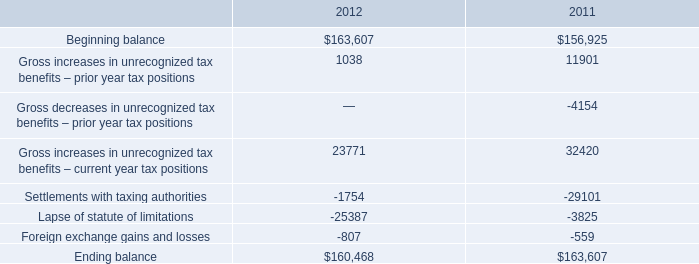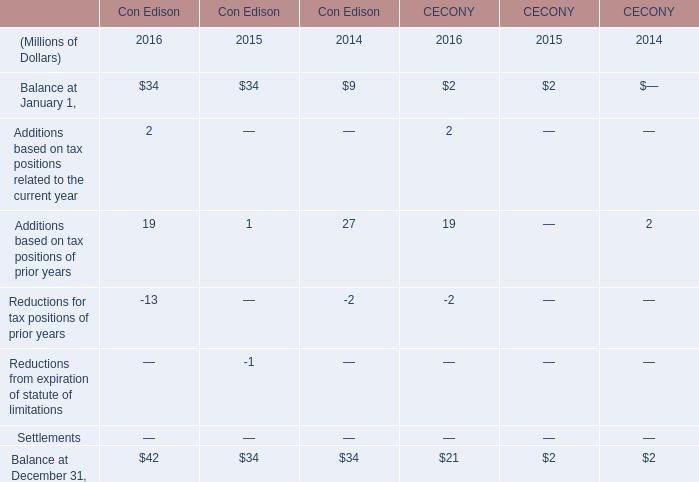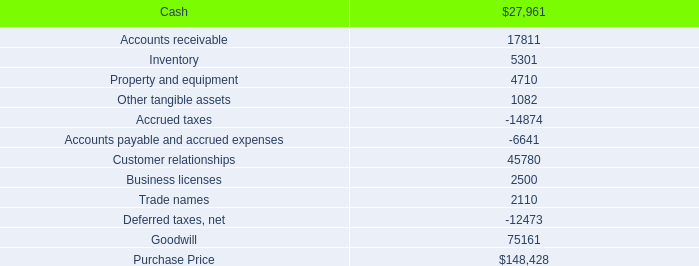What is the total amount of Ending balance of 2011, and Accounts payable and accrued expenses ? 
Computations: (163607.0 + 6641.0)
Answer: 170248.0. 